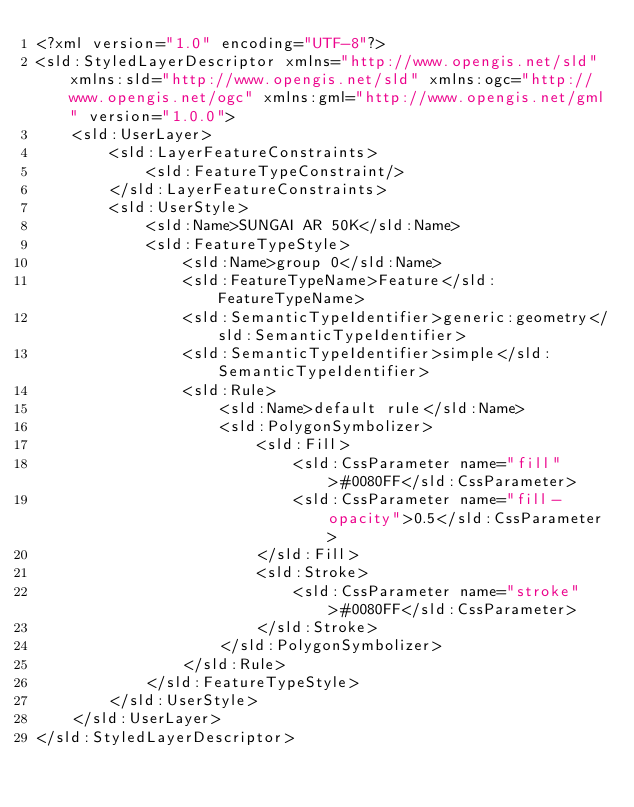Convert code to text. <code><loc_0><loc_0><loc_500><loc_500><_Scheme_><?xml version="1.0" encoding="UTF-8"?>
<sld:StyledLayerDescriptor xmlns="http://www.opengis.net/sld" xmlns:sld="http://www.opengis.net/sld" xmlns:ogc="http://www.opengis.net/ogc" xmlns:gml="http://www.opengis.net/gml" version="1.0.0">
    <sld:UserLayer>
        <sld:LayerFeatureConstraints>
            <sld:FeatureTypeConstraint/>
        </sld:LayerFeatureConstraints>
        <sld:UserStyle>
            <sld:Name>SUNGAI AR 50K</sld:Name>
            <sld:FeatureTypeStyle>
                <sld:Name>group 0</sld:Name>
                <sld:FeatureTypeName>Feature</sld:FeatureTypeName>
                <sld:SemanticTypeIdentifier>generic:geometry</sld:SemanticTypeIdentifier>
                <sld:SemanticTypeIdentifier>simple</sld:SemanticTypeIdentifier>
                <sld:Rule>
                    <sld:Name>default rule</sld:Name>
                    <sld:PolygonSymbolizer>
                        <sld:Fill>
                            <sld:CssParameter name="fill">#0080FF</sld:CssParameter>
                            <sld:CssParameter name="fill-opacity">0.5</sld:CssParameter>
                        </sld:Fill>
                        <sld:Stroke>
                            <sld:CssParameter name="stroke">#0080FF</sld:CssParameter>
                        </sld:Stroke>
                    </sld:PolygonSymbolizer>
                </sld:Rule>
            </sld:FeatureTypeStyle>
        </sld:UserStyle>
    </sld:UserLayer>
</sld:StyledLayerDescriptor>

</code> 